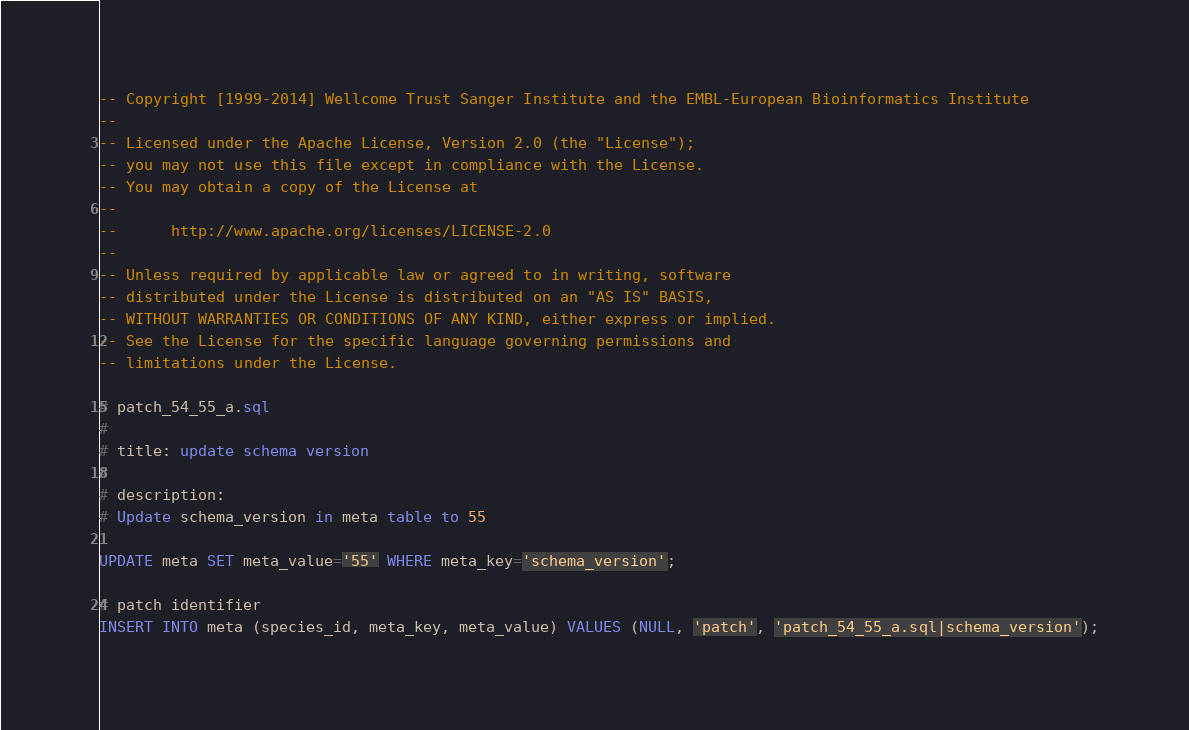<code> <loc_0><loc_0><loc_500><loc_500><_SQL_>-- Copyright [1999-2014] Wellcome Trust Sanger Institute and the EMBL-European Bioinformatics Institute
-- 
-- Licensed under the Apache License, Version 2.0 (the "License");
-- you may not use this file except in compliance with the License.
-- You may obtain a copy of the License at
-- 
--      http://www.apache.org/licenses/LICENSE-2.0
-- 
-- Unless required by applicable law or agreed to in writing, software
-- distributed under the License is distributed on an "AS IS" BASIS,
-- WITHOUT WARRANTIES OR CONDITIONS OF ANY KIND, either express or implied.
-- See the License for the specific language governing permissions and
-- limitations under the License.

# patch_54_55_a.sql
#
# title: update schema version
#
# description:
# Update schema_version in meta table to 55

UPDATE meta SET meta_value='55' WHERE meta_key='schema_version';

# patch identifier
INSERT INTO meta (species_id, meta_key, meta_value) VALUES (NULL, 'patch', 'patch_54_55_a.sql|schema_version');


</code> 